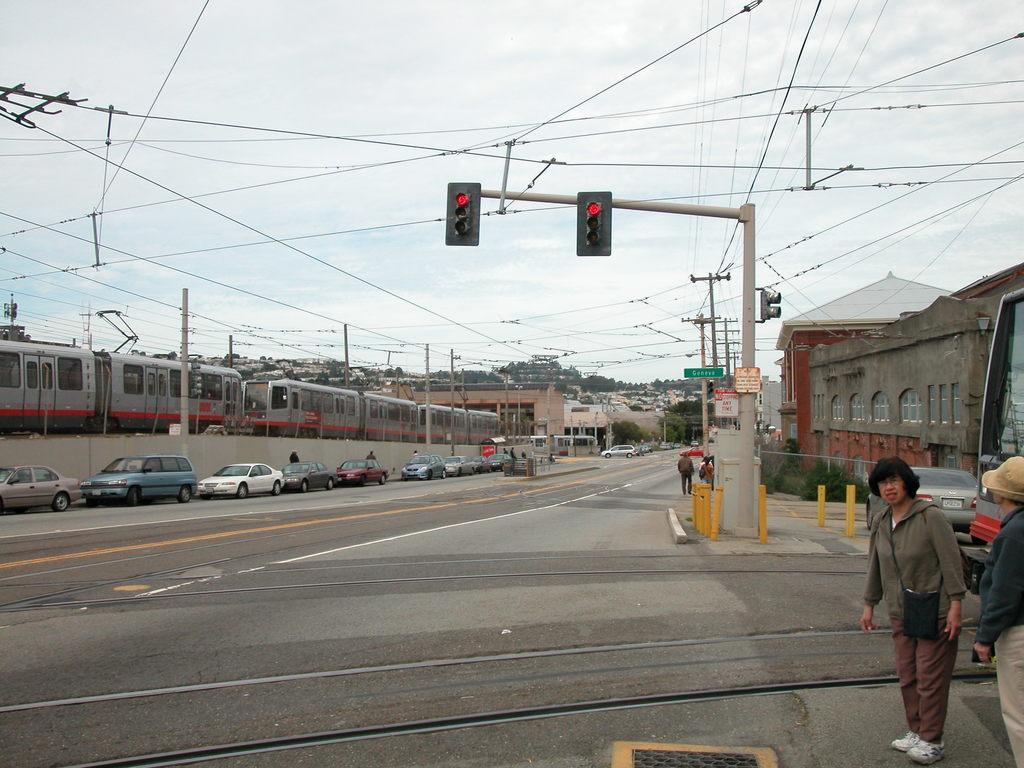In one or two sentences, can you explain what this image depicts? In this image we can see train, poles, wires, traffic lights, boards, cars, road, trees, building are there. At the top of the image sky is there. At the bottom of the image road is there. On the right side of the image some persons are there. 